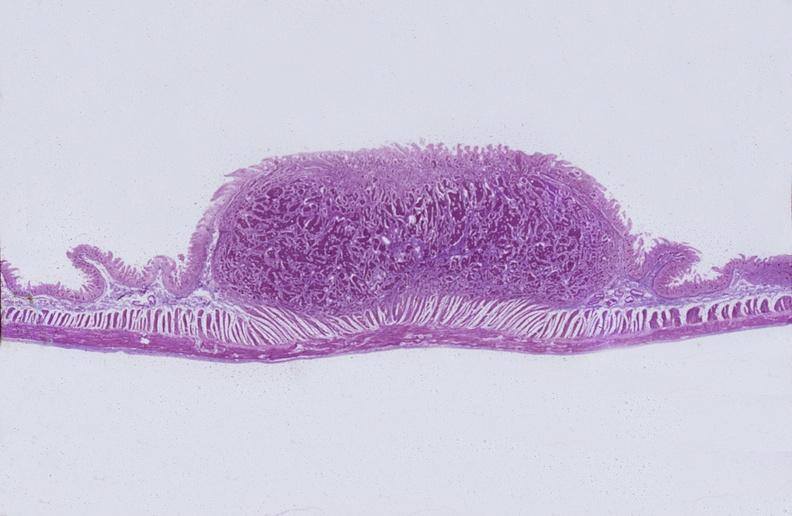s gastrointestinal present?
Answer the question using a single word or phrase. Yes 